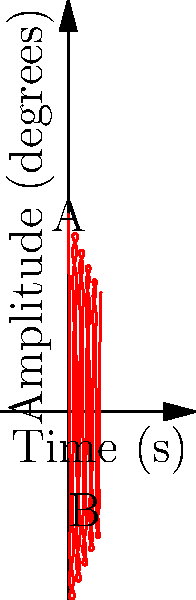The graph shows the oscillation of a balance wheel in a mechanical watch over time. The amplitude decays exponentially due to friction. If the initial amplitude at point A is 30°, what is the approximate amplitude at point B after 2.5 seconds? Express your answer in degrees, rounded to the nearest whole number. To solve this problem, we need to analyze the exponential decay of the oscillation amplitude:

1. The general equation for exponential decay is:
   $A(t) = A_0 e^{-\lambda t}$
   Where $A(t)$ is the amplitude at time $t$, $A_0$ is the initial amplitude, and $\lambda$ is the decay constant.

2. We're given:
   - Initial amplitude $A_0 = 30°$
   - Time $t = 2.5$ seconds

3. From the graph, we can estimate the decay constant $\lambda$. The envelope of the oscillation appears to decay to about 1/3 of its initial value after 5 seconds. Using this:
   $\frac{1}{3} = e^{-5\lambda}$
   $\ln(\frac{1}{3}) = -5\lambda$
   $\lambda \approx 0.22$

4. Now we can calculate the amplitude at 2.5 seconds:
   $A(2.5) = 30 \cdot e^{-0.22 \cdot 2.5}$
   $A(2.5) \approx 30 \cdot e^{-0.55}$
   $A(2.5) \approx 30 \cdot 0.58$
   $A(2.5) \approx 17.4°$

5. However, this is the envelope amplitude. The actual amplitude at point B is negative, so we need to multiply by -1:
   $A(2.5) \approx -17.4°$

6. Rounding to the nearest whole number:
   $A(2.5) \approx -17°$
Answer: -17° 